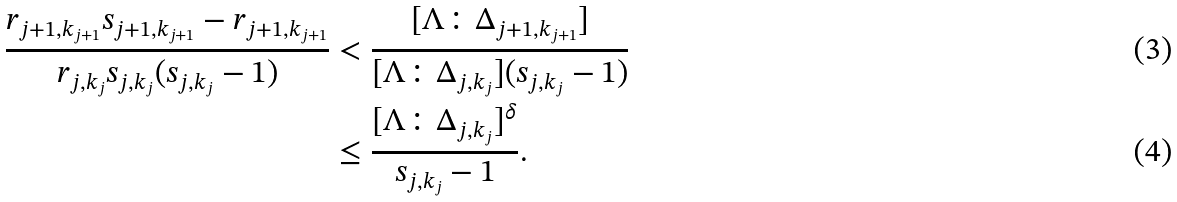<formula> <loc_0><loc_0><loc_500><loc_500>\frac { r _ { j + 1 , k _ { j + 1 } } s _ { j + 1 , k _ { j + 1 } } - r _ { j + 1 , k _ { j + 1 } } } { r _ { j , k _ { j } } s _ { j , k _ { j } } ( s _ { j , k _ { j } } - 1 ) } & < \frac { [ \Lambda \colon \Delta _ { j + 1 , k _ { j + 1 } } ] } { [ \Lambda \colon \Delta _ { j , k _ { j } } ] ( s _ { j , k _ { j } } - 1 ) } \\ & \leq \frac { [ \Lambda \colon \Delta _ { j , k _ { j } } ] ^ { \delta } } { s _ { j , k _ { j } } - 1 } .</formula> 